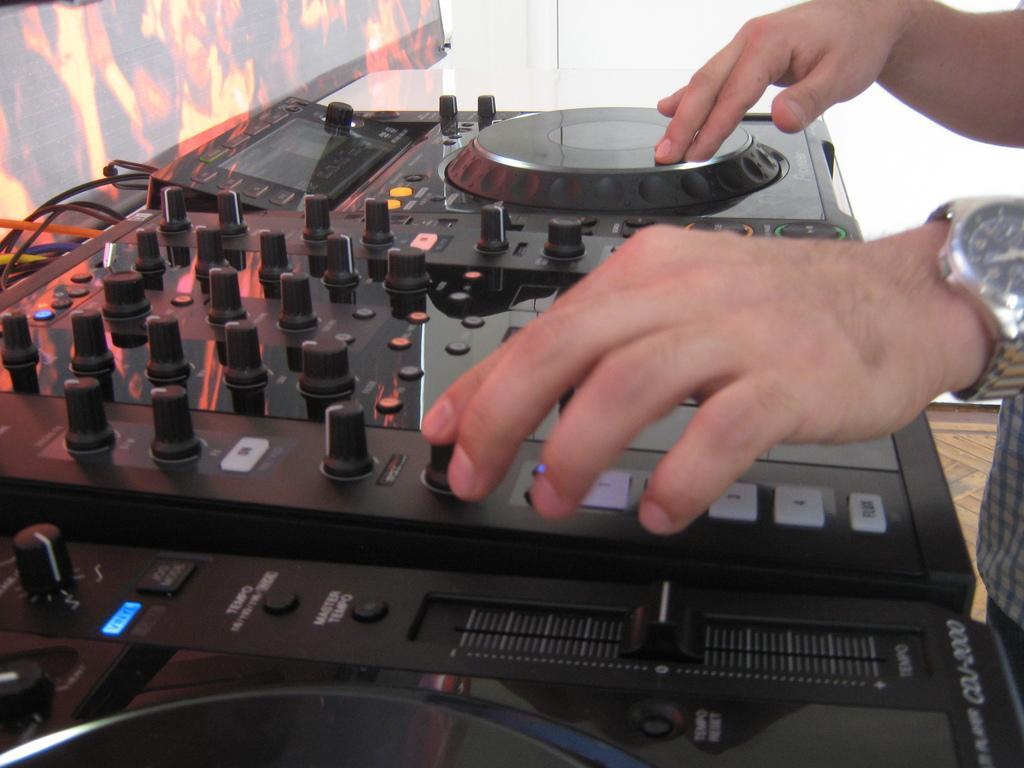Please provide a concise description of this image. The picture consists of a music controlling machine. On the right there is a person standing. On the left there is a poster. At the top it is well. 